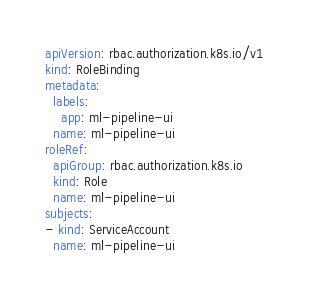Convert code to text. <code><loc_0><loc_0><loc_500><loc_500><_YAML_>apiVersion: rbac.authorization.k8s.io/v1
kind: RoleBinding
metadata:
  labels:
    app: ml-pipeline-ui
  name: ml-pipeline-ui
roleRef:
  apiGroup: rbac.authorization.k8s.io
  kind: Role
  name: ml-pipeline-ui
subjects:
- kind: ServiceAccount
  name: ml-pipeline-ui
</code> 